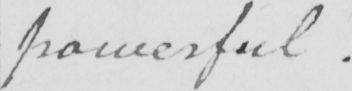Can you read and transcribe this handwriting? powerful . 